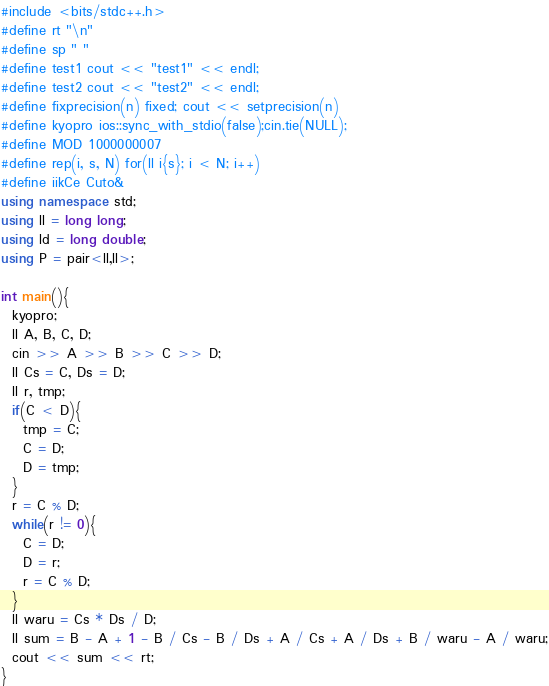<code> <loc_0><loc_0><loc_500><loc_500><_C++_>#include <bits/stdc++.h>
#define rt "\n"
#define sp " "
#define test1 cout << "test1" << endl;
#define test2 cout << "test2" << endl;
#define fixprecision(n) fixed; cout << setprecision(n)
#define kyopro ios::sync_with_stdio(false);cin.tie(NULL);
#define MOD 1000000007
#define rep(i, s, N) for(ll i{s}; i < N; i++)
#define iikCe Cuto&
using namespace std;
using ll = long long;
using ld = long double;
using P = pair<ll,ll>;

int main(){
  kyopro;
  ll A, B, C, D;
  cin >> A >> B >> C >> D;
  ll Cs = C, Ds = D;
  ll r, tmp;
  if(C < D){
    tmp = C;
    C = D;
    D = tmp;
  }
  r = C % D;
  while(r != 0){
    C = D;
    D = r;
    r = C % D;
  }
  ll waru = Cs * Ds / D;
  ll sum = B - A + 1 - B / Cs - B / Ds + A / Cs + A / Ds + B / waru - A / waru;
  cout << sum << rt;
}</code> 